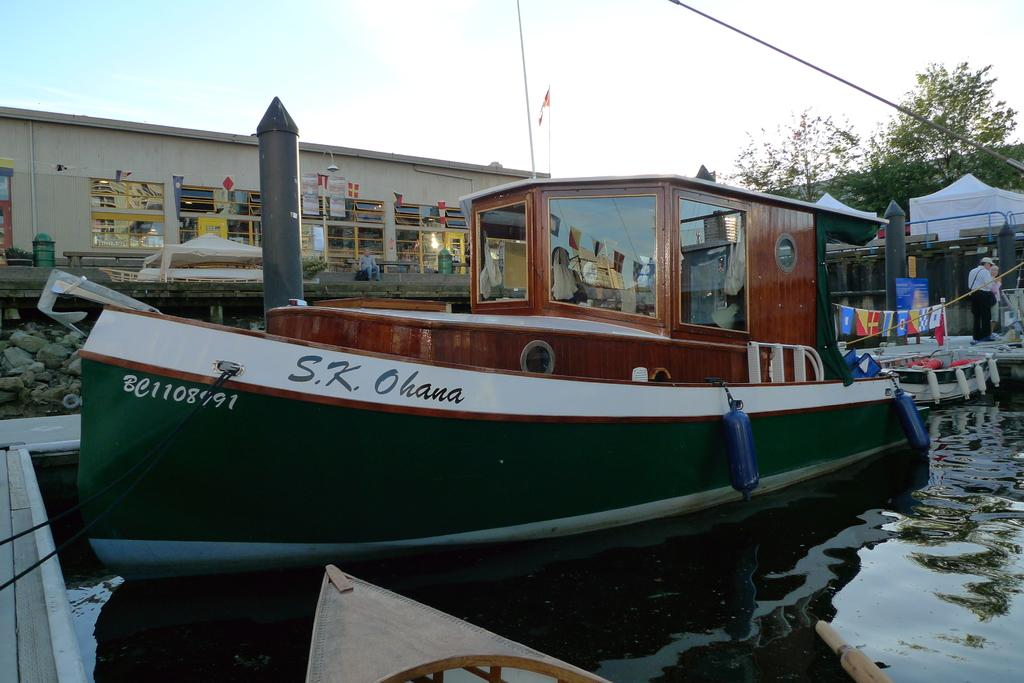What is the main subject of the image? The main subject of the image is a ship. Where is the ship located? The ship is on water. What can be seen in the background of the image? There is a building in the background of the image. How many people are visible in the image? There are two people standing on the left side of the image. What type of vegetation is present in the image? There are trees present in the image. What type of animals can be seen at the zoo in the image? There is no zoo present in the image; it features a ship on water with a building in the background and two people standing on the left side. 